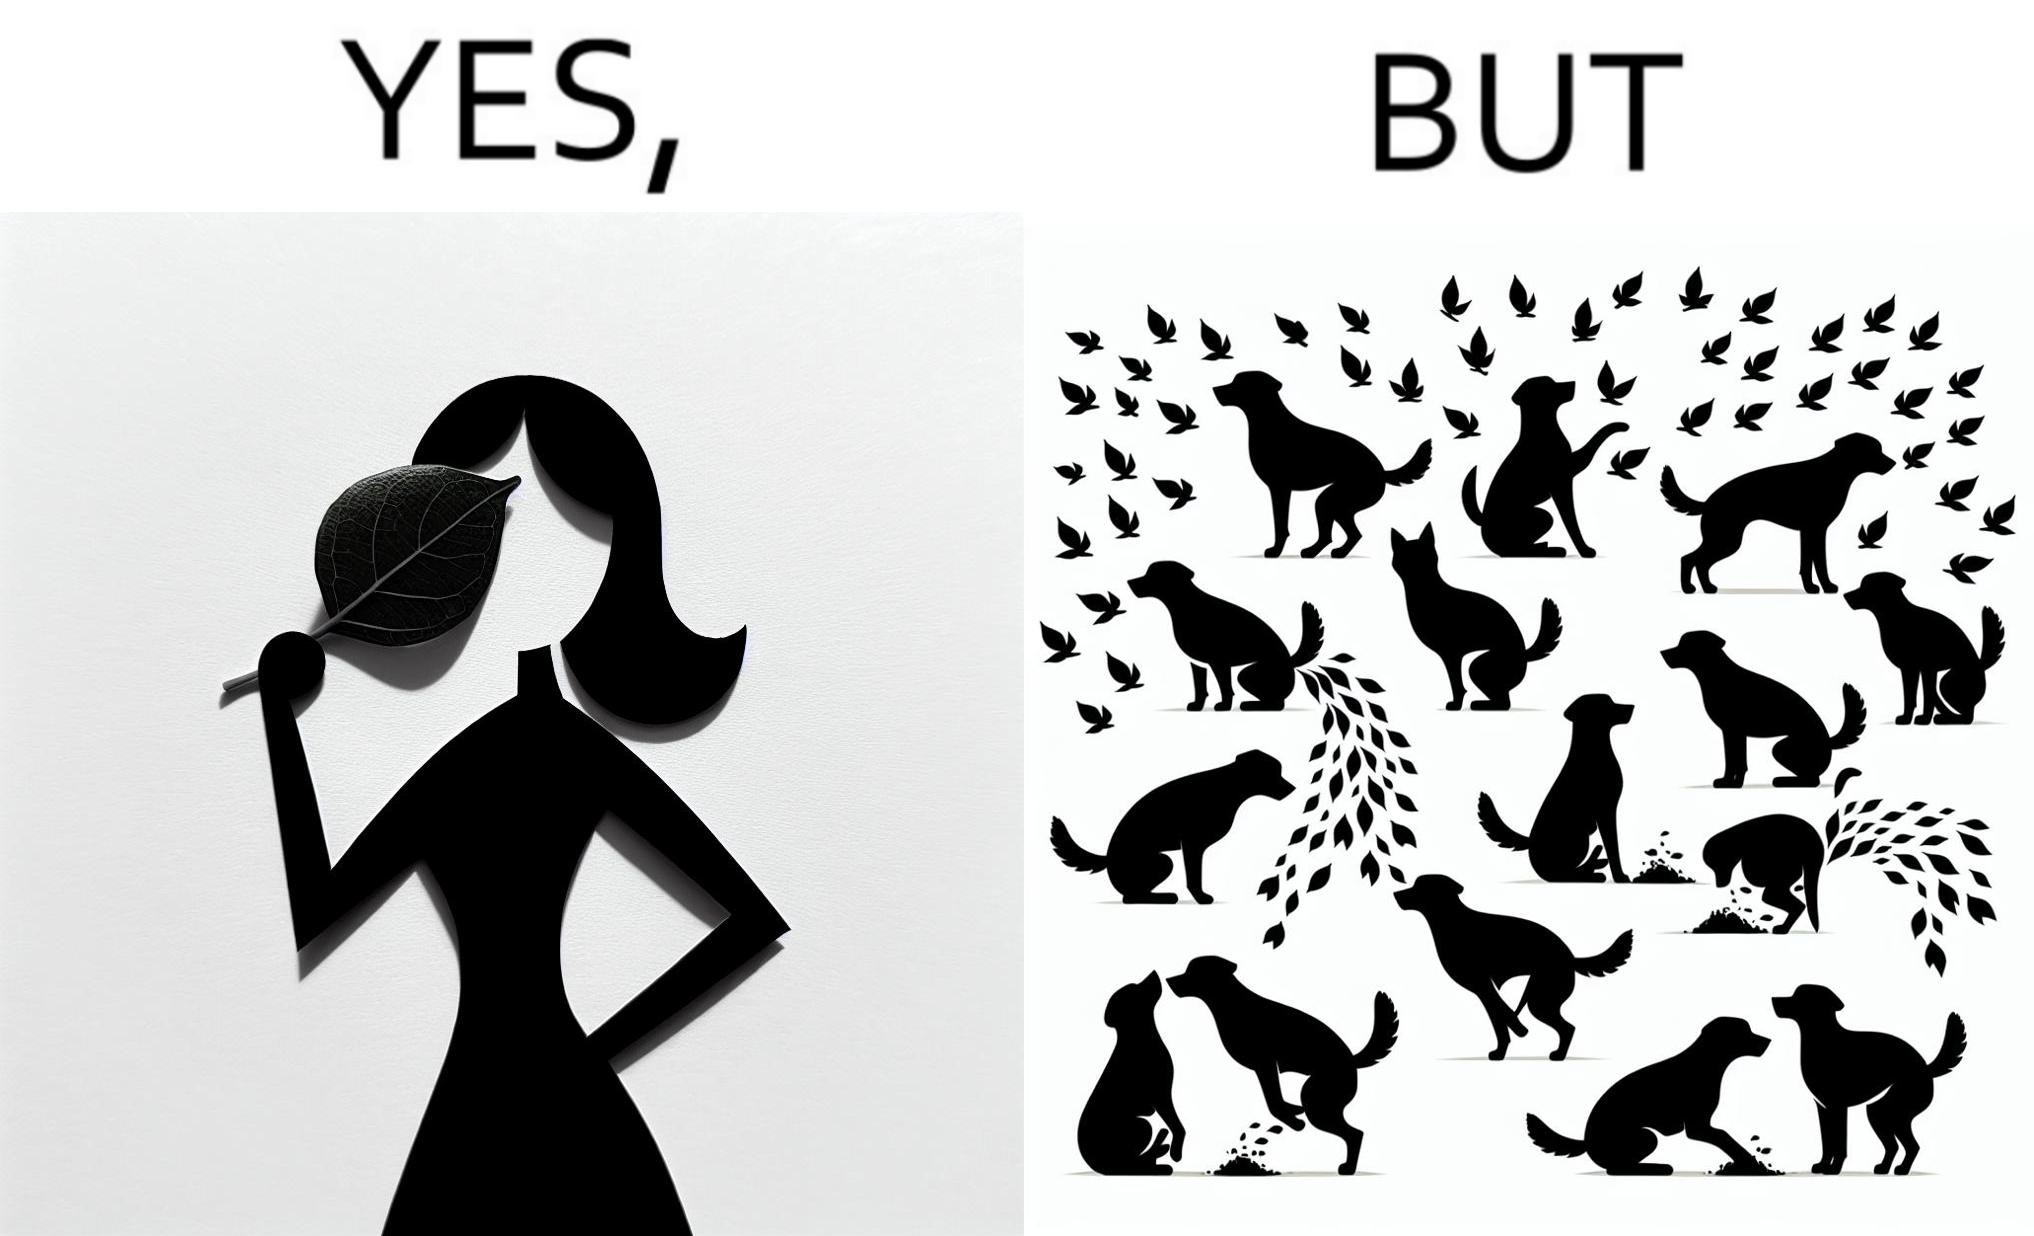Is this a satirical image? Yes, this image is satirical. 